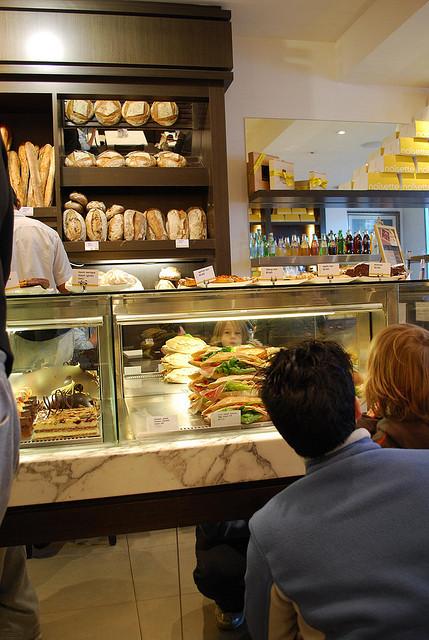What kind of job does this man hold?
Give a very brief answer. Baker. Could this collection be called a collage?
Write a very short answer. No. What color shirt is the man on the right wearing?
Give a very brief answer. Blue. Are there sandwiches in the display cases?
Give a very brief answer. Yes. Is the child working the deli?
Quick response, please. No. 